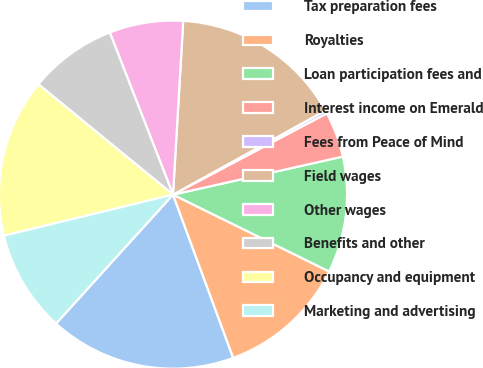Convert chart to OTSL. <chart><loc_0><loc_0><loc_500><loc_500><pie_chart><fcel>Tax preparation fees<fcel>Royalties<fcel>Loan participation fees and<fcel>Interest income on Emerald<fcel>Fees from Peace of Mind<fcel>Field wages<fcel>Other wages<fcel>Benefits and other<fcel>Occupancy and equipment<fcel>Marketing and advertising<nl><fcel>17.35%<fcel>12.1%<fcel>10.79%<fcel>4.23%<fcel>0.29%<fcel>16.04%<fcel>6.85%<fcel>8.16%<fcel>14.72%<fcel>9.48%<nl></chart> 